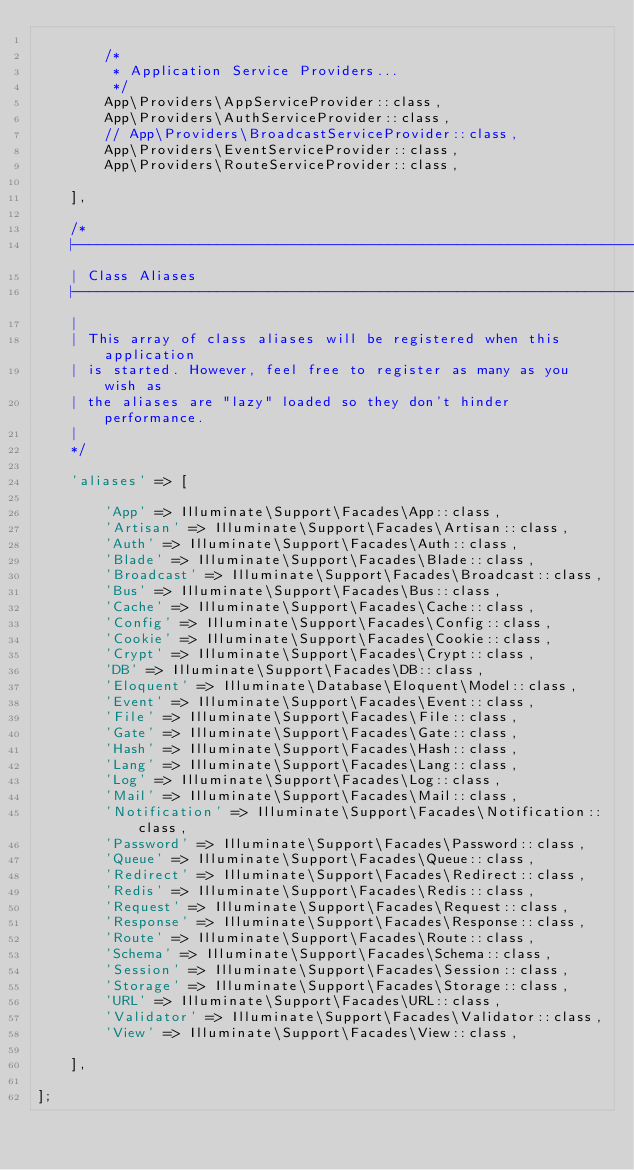<code> <loc_0><loc_0><loc_500><loc_500><_PHP_>
        /*
         * Application Service Providers...
         */
        App\Providers\AppServiceProvider::class,
        App\Providers\AuthServiceProvider::class,
        // App\Providers\BroadcastServiceProvider::class,
        App\Providers\EventServiceProvider::class,
        App\Providers\RouteServiceProvider::class,

    ],

    /*
    |--------------------------------------------------------------------------
    | Class Aliases
    |--------------------------------------------------------------------------
    |
    | This array of class aliases will be registered when this application
    | is started. However, feel free to register as many as you wish as
    | the aliases are "lazy" loaded so they don't hinder performance.
    |
    */

    'aliases' => [

        'App' => Illuminate\Support\Facades\App::class,
        'Artisan' => Illuminate\Support\Facades\Artisan::class,
        'Auth' => Illuminate\Support\Facades\Auth::class,
        'Blade' => Illuminate\Support\Facades\Blade::class,
        'Broadcast' => Illuminate\Support\Facades\Broadcast::class,
        'Bus' => Illuminate\Support\Facades\Bus::class,
        'Cache' => Illuminate\Support\Facades\Cache::class,
        'Config' => Illuminate\Support\Facades\Config::class,
        'Cookie' => Illuminate\Support\Facades\Cookie::class,
        'Crypt' => Illuminate\Support\Facades\Crypt::class,
        'DB' => Illuminate\Support\Facades\DB::class,
        'Eloquent' => Illuminate\Database\Eloquent\Model::class,
        'Event' => Illuminate\Support\Facades\Event::class,
        'File' => Illuminate\Support\Facades\File::class,
        'Gate' => Illuminate\Support\Facades\Gate::class,
        'Hash' => Illuminate\Support\Facades\Hash::class,
        'Lang' => Illuminate\Support\Facades\Lang::class,
        'Log' => Illuminate\Support\Facades\Log::class,
        'Mail' => Illuminate\Support\Facades\Mail::class,
        'Notification' => Illuminate\Support\Facades\Notification::class,
        'Password' => Illuminate\Support\Facades\Password::class,
        'Queue' => Illuminate\Support\Facades\Queue::class,
        'Redirect' => Illuminate\Support\Facades\Redirect::class,
        'Redis' => Illuminate\Support\Facades\Redis::class,
        'Request' => Illuminate\Support\Facades\Request::class,
        'Response' => Illuminate\Support\Facades\Response::class,
        'Route' => Illuminate\Support\Facades\Route::class,
        'Schema' => Illuminate\Support\Facades\Schema::class,
        'Session' => Illuminate\Support\Facades\Session::class,
        'Storage' => Illuminate\Support\Facades\Storage::class,
        'URL' => Illuminate\Support\Facades\URL::class,
        'Validator' => Illuminate\Support\Facades\Validator::class,
        'View' => Illuminate\Support\Facades\View::class,

    ],

];
</code> 